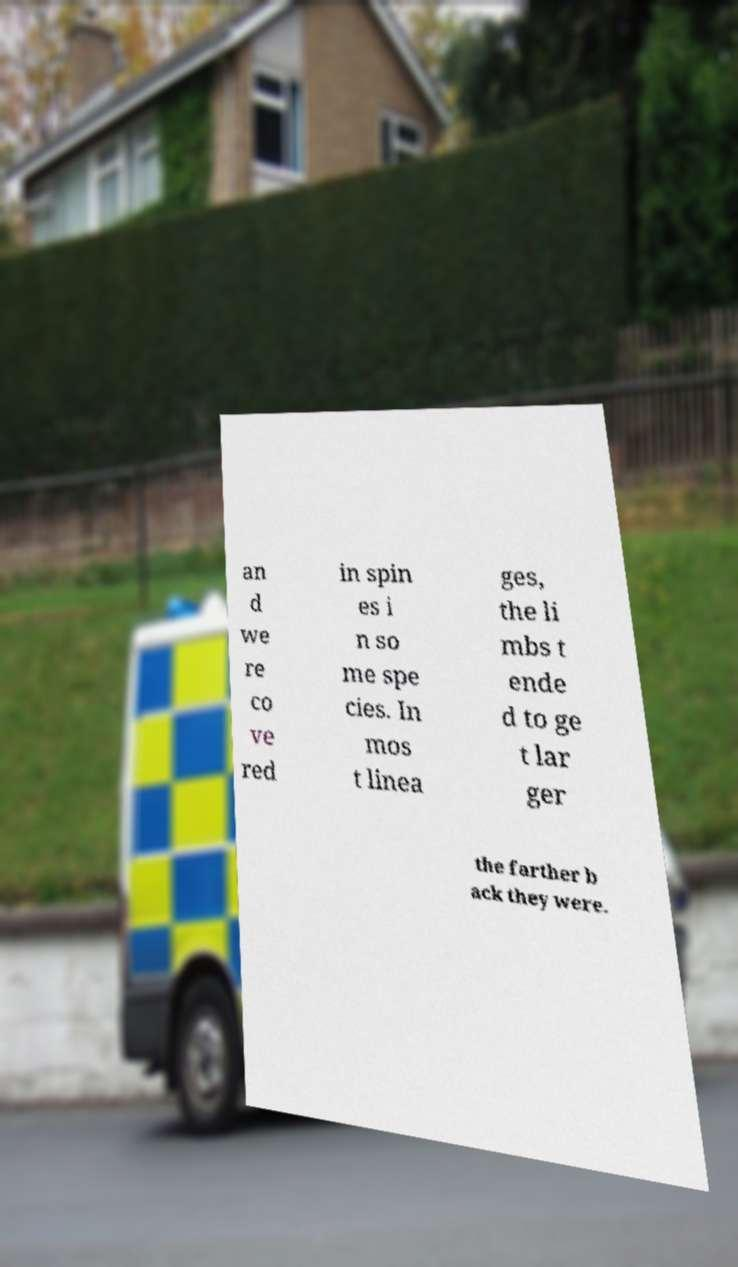For documentation purposes, I need the text within this image transcribed. Could you provide that? an d we re co ve red in spin es i n so me spe cies. In mos t linea ges, the li mbs t ende d to ge t lar ger the farther b ack they were. 